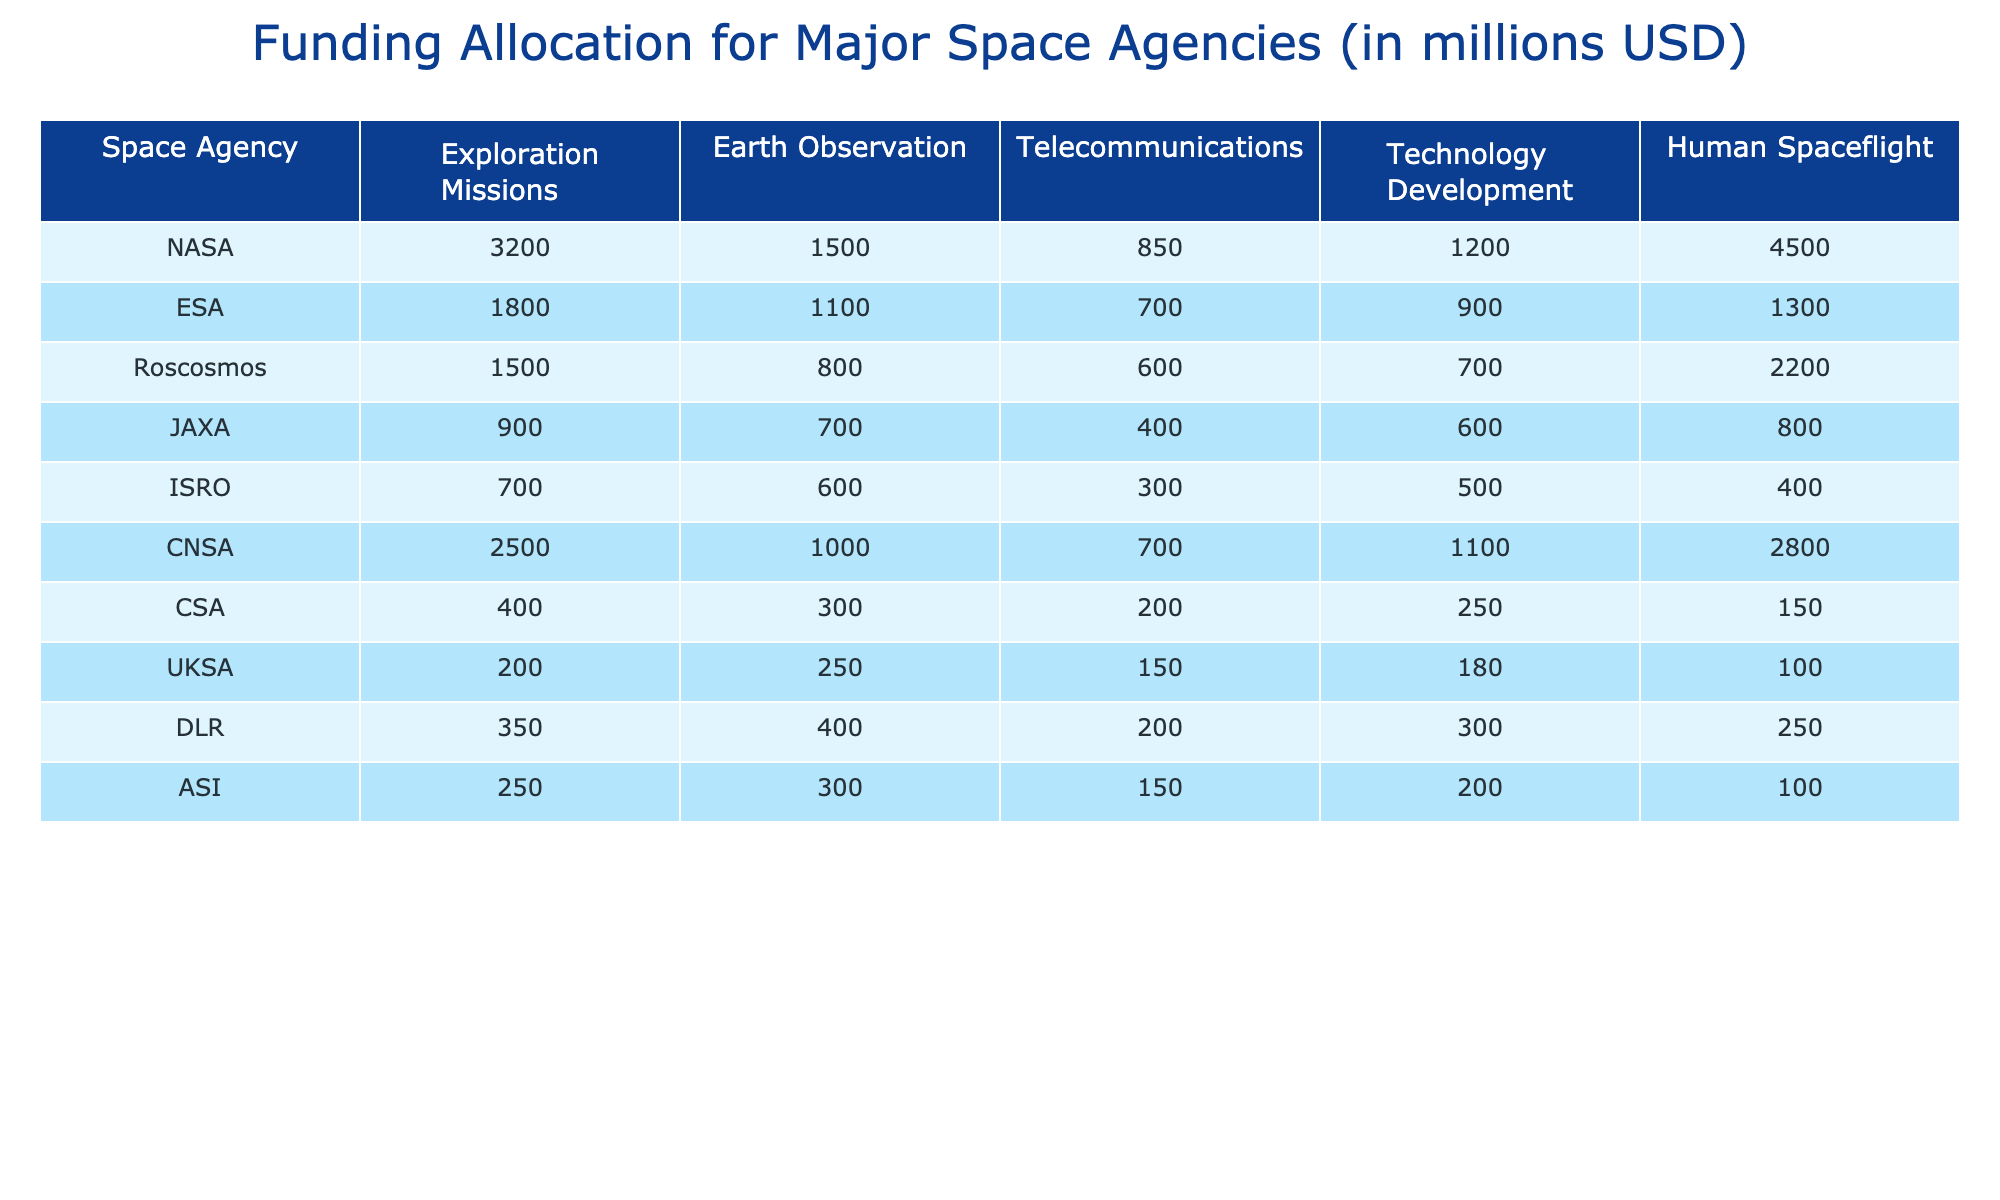What is the total funding for NASA across all mission categories? To find the total funding for NASA, I will sum the values in all the mission categories: 3200 + 1500 + 850 + 1200 + 4500 = 10750.
Answer: 10750 Which agency has the highest funding for Human Spaceflight? Looking at the Human Spaceflight column, NASA has the highest funding at 4500 million USD.
Answer: NASA What is the funding difference between ESA and Roscosmos for Earth Observation missions? The funding for ESA in Earth Observation missions is 1100 million USD, while Roscosmos is 800 million USD. The difference is 1100 - 800 = 300 million USD.
Answer: 300 How much total funding do the space agencies allocate to Exploration Missions? Adding the funding for Exploration Missions: 3200 (NASA) + 1800 (ESA) + 1500 (Roscosmos) + 900 (JAXA) + 700 (ISRO) + 2500 (CNSA) + 400 (CSA) + 200 (UKSA) + 350 (DLR) + 250 (ASI) = 10700 million USD.
Answer: 10700 Is ISRO's funding for Telecommunications higher than CSA's? ISRO's funding for Telecommunications is 300 million USD, while CSA's is 200 million USD. Therefore, ISRO has higher funding.
Answer: Yes Which agency has the least funding for Technology Development? In the Technology Development category, CSA has 250 million USD, which is the least among all agencies.
Answer: CSA What is the average funding allotted to Earth Observation by all agencies? The total funding for Earth Observation is 1500 (NASA) + 1100 (ESA) + 800 (Roscosmos) + 700 (JAXA) + 600 (ISRO) + 1000 (CNSA) + 300 (CSA) + 250 (UKSA) + 400 (DLR) + 300 (ASI) = 6600 million USD. There are 10 agencies, therefore the average is 6600 / 10 = 660.
Answer: 660 Which agency allocates more than 2000 million USD to total funding? A quick review of the total funding: NASA (10750), CNSA (7500), and Roscosmos (2200) all allocate more than 2000 million USD.
Answer: NASA, CNSA, Roscosmos How much more does NASA allocate to Human Spaceflight compared to JAXA? The funding for Human Spaceflight for NASA is 4500 million USD, while JAXA is 800 million USD. Therefore, the difference is 4500 - 800 = 3700 million USD.
Answer: 3700 If we combine the total funding of ESA and ISRO, what will that be? ESA's funding is 1800 million USD and ISRO's is 400 million USD. Adding these gives 1800 + 400 = 2200 million USD.
Answer: 2200 